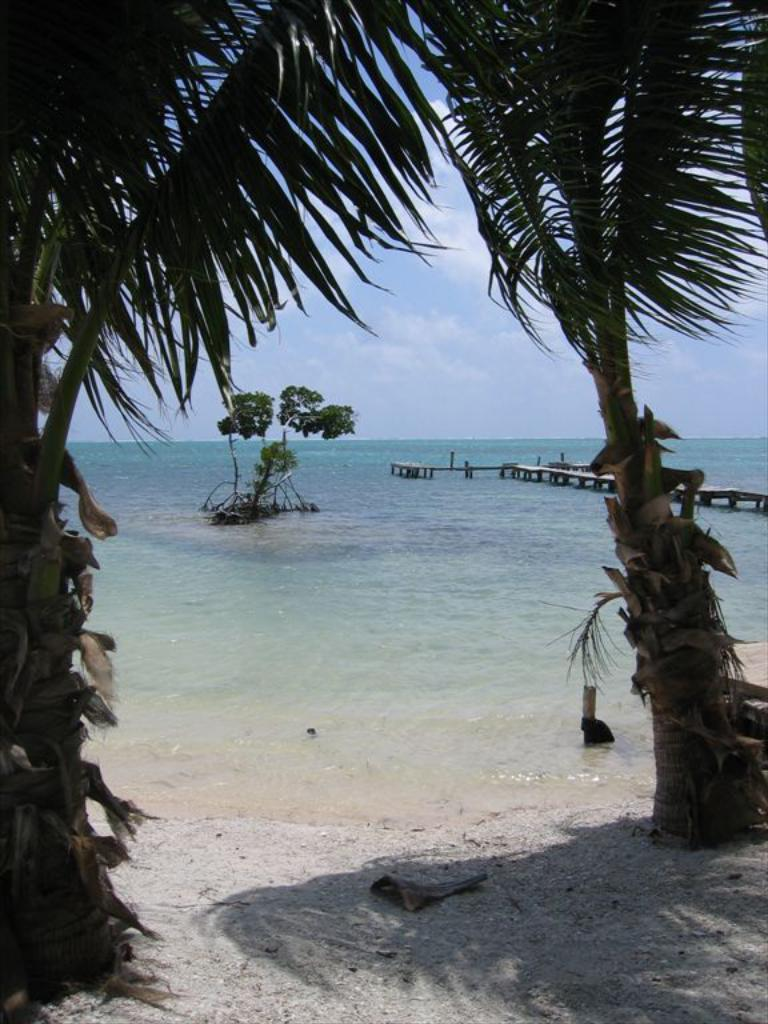What can be seen in the image? There is water visible in the image, and there are trees present as well. Can you describe the water in the image? The water is visible, but its specific characteristics are not mentioned in the facts. What type of vegetation is in the image? The trees in the image are a type of vegetation. What flavor of rub can be seen on the lock in the image? There is no lock or rub present in the image; it only features water and trees. 